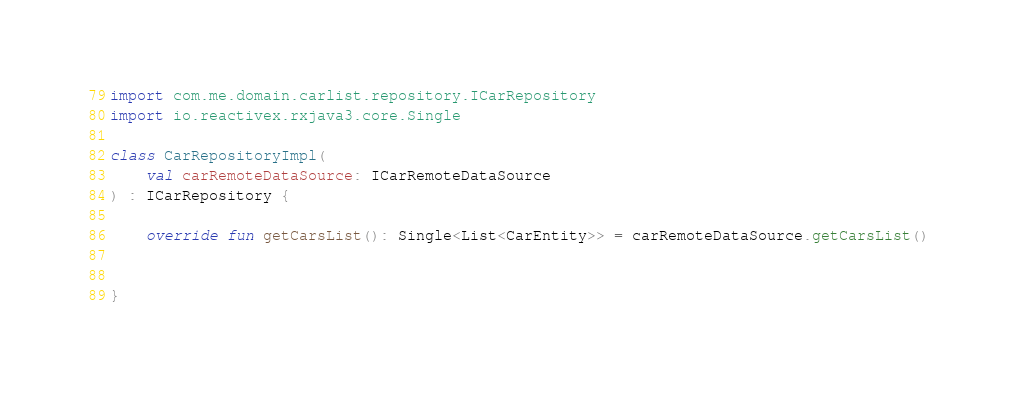Convert code to text. <code><loc_0><loc_0><loc_500><loc_500><_Kotlin_>import com.me.domain.carlist.repository.ICarRepository
import io.reactivex.rxjava3.core.Single

class CarRepositoryImpl(
    val carRemoteDataSource: ICarRemoteDataSource
) : ICarRepository {

    override fun getCarsList(): Single<List<CarEntity>> = carRemoteDataSource.getCarsList()


}</code> 